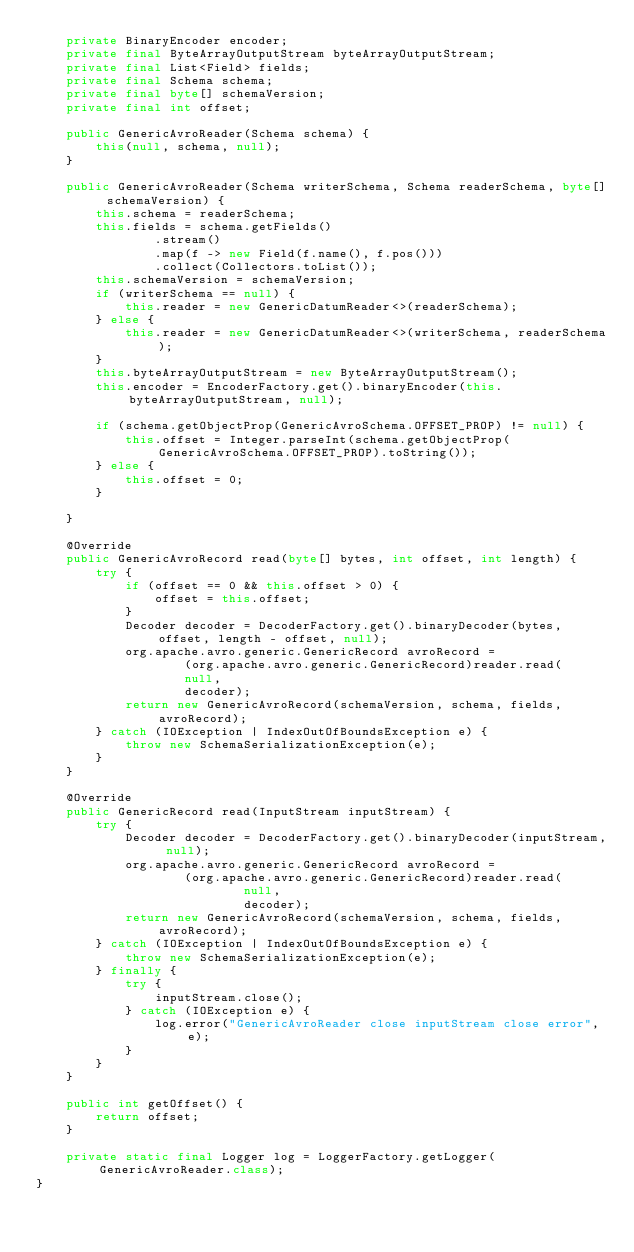Convert code to text. <code><loc_0><loc_0><loc_500><loc_500><_Java_>    private BinaryEncoder encoder;
    private final ByteArrayOutputStream byteArrayOutputStream;
    private final List<Field> fields;
    private final Schema schema;
    private final byte[] schemaVersion;
    private final int offset;

    public GenericAvroReader(Schema schema) {
        this(null, schema, null);
    }

    public GenericAvroReader(Schema writerSchema, Schema readerSchema, byte[] schemaVersion) {
        this.schema = readerSchema;
        this.fields = schema.getFields()
                .stream()
                .map(f -> new Field(f.name(), f.pos()))
                .collect(Collectors.toList());
        this.schemaVersion = schemaVersion;
        if (writerSchema == null) {
            this.reader = new GenericDatumReader<>(readerSchema);
        } else {
            this.reader = new GenericDatumReader<>(writerSchema, readerSchema);
        }
        this.byteArrayOutputStream = new ByteArrayOutputStream();
        this.encoder = EncoderFactory.get().binaryEncoder(this.byteArrayOutputStream, null);

        if (schema.getObjectProp(GenericAvroSchema.OFFSET_PROP) != null) {
            this.offset = Integer.parseInt(schema.getObjectProp(GenericAvroSchema.OFFSET_PROP).toString());
        } else {
            this.offset = 0;
        }

    }

    @Override
    public GenericAvroRecord read(byte[] bytes, int offset, int length) {
        try {
            if (offset == 0 && this.offset > 0) {
                offset = this.offset;
            }
            Decoder decoder = DecoderFactory.get().binaryDecoder(bytes, offset, length - offset, null);
            org.apache.avro.generic.GenericRecord avroRecord =
                    (org.apache.avro.generic.GenericRecord)reader.read(
                    null,
                    decoder);
            return new GenericAvroRecord(schemaVersion, schema, fields, avroRecord);
        } catch (IOException | IndexOutOfBoundsException e) {
            throw new SchemaSerializationException(e);
        }
    }

    @Override
    public GenericRecord read(InputStream inputStream) {
        try {
            Decoder decoder = DecoderFactory.get().binaryDecoder(inputStream, null);
            org.apache.avro.generic.GenericRecord avroRecord =
                    (org.apache.avro.generic.GenericRecord)reader.read(
                            null,
                            decoder);
            return new GenericAvroRecord(schemaVersion, schema, fields, avroRecord);
        } catch (IOException | IndexOutOfBoundsException e) {
            throw new SchemaSerializationException(e);
        } finally {
            try {
                inputStream.close();
            } catch (IOException e) {
                log.error("GenericAvroReader close inputStream close error", e);
            }
        }
    }

    public int getOffset() {
        return offset;
    }

    private static final Logger log = LoggerFactory.getLogger(GenericAvroReader.class);
}
</code> 